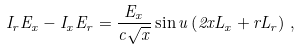<formula> <loc_0><loc_0><loc_500><loc_500>I _ { r } E _ { x } - I _ { x } E _ { r } = \frac { E _ { x } } { c \sqrt { x } } \sin u \left ( 2 x L _ { x } + r L _ { r } \right ) \, ,</formula> 